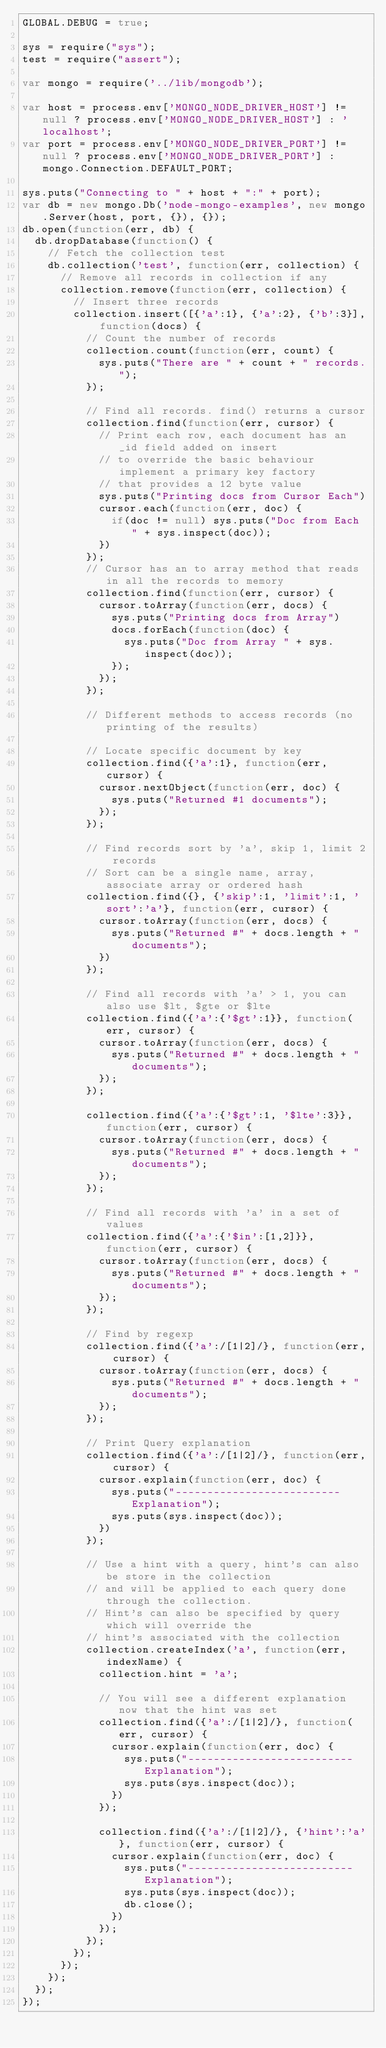<code> <loc_0><loc_0><loc_500><loc_500><_JavaScript_>GLOBAL.DEBUG = true;

sys = require("sys");
test = require("assert");

var mongo = require('../lib/mongodb');

var host = process.env['MONGO_NODE_DRIVER_HOST'] != null ? process.env['MONGO_NODE_DRIVER_HOST'] : 'localhost';
var port = process.env['MONGO_NODE_DRIVER_PORT'] != null ? process.env['MONGO_NODE_DRIVER_PORT'] : mongo.Connection.DEFAULT_PORT;

sys.puts("Connecting to " + host + ":" + port);
var db = new mongo.Db('node-mongo-examples', new mongo.Server(host, port, {}), {});
db.open(function(err, db) {
  db.dropDatabase(function() {
    // Fetch the collection test
    db.collection('test', function(err, collection) {
      // Remove all records in collection if any
      collection.remove(function(err, collection) {
        // Insert three records
        collection.insert([{'a':1}, {'a':2}, {'b':3}], function(docs) {
          // Count the number of records
          collection.count(function(err, count) {
            sys.puts("There are " + count + " records.");
          });
          
          // Find all records. find() returns a cursor
          collection.find(function(err, cursor) {
            // Print each row, each document has an _id field added on insert
            // to override the basic behaviour implement a primary key factory
            // that provides a 12 byte value
            sys.puts("Printing docs from Cursor Each")
            cursor.each(function(err, doc) {
              if(doc != null) sys.puts("Doc from Each " + sys.inspect(doc));
            })                    
          });
          // Cursor has an to array method that reads in all the records to memory
          collection.find(function(err, cursor) {
            cursor.toArray(function(err, docs) {
              sys.puts("Printing docs from Array")
              docs.forEach(function(doc) {
                sys.puts("Doc from Array " + sys.inspect(doc));
              });
            });
          });
          
          // Different methods to access records (no printing of the results)
          
          // Locate specific document by key
          collection.find({'a':1}, function(err, cursor) {
            cursor.nextObject(function(err, doc) {            
              sys.puts("Returned #1 documents");
            });
          });
          
          // Find records sort by 'a', skip 1, limit 2 records
          // Sort can be a single name, array, associate array or ordered hash
          collection.find({}, {'skip':1, 'limit':1, 'sort':'a'}, function(err, cursor) {
            cursor.toArray(function(err, docs) {            
              sys.puts("Returned #" + docs.length + " documents");
            })          
          });
          
          // Find all records with 'a' > 1, you can also use $lt, $gte or $lte
          collection.find({'a':{'$gt':1}}, function(err, cursor) {
            cursor.toArray(function(err, docs) {
              sys.puts("Returned #" + docs.length + " documents");
            });
          });
          
          collection.find({'a':{'$gt':1, '$lte':3}}, function(err, cursor) {
            cursor.toArray(function(err, docs) {
              sys.puts("Returned #" + docs.length + " documents");
            });          
          });
          
          // Find all records with 'a' in a set of values
          collection.find({'a':{'$in':[1,2]}}, function(err, cursor) {
            cursor.toArray(function(err, docs) {
              sys.puts("Returned #" + docs.length + " documents");
            });          
          });
          
          // Find by regexp
          collection.find({'a':/[1|2]/}, function(err, cursor) {
            cursor.toArray(function(err, docs) {
              sys.puts("Returned #" + docs.length + " documents");
            });          
          });

          // Print Query explanation
          collection.find({'a':/[1|2]/}, function(err, cursor) {
            cursor.explain(function(err, doc) {
              sys.puts("-------------------------- Explanation");
              sys.puts(sys.inspect(doc));
            })
          });

          // Use a hint with a query, hint's can also be store in the collection
          // and will be applied to each query done through the collection.
          // Hint's can also be specified by query which will override the 
          // hint's associated with the collection
          collection.createIndex('a', function(err, indexName) {
            collection.hint = 'a';

            // You will see a different explanation now that the hint was set
            collection.find({'a':/[1|2]/}, function(err, cursor) {
              cursor.explain(function(err, doc) {
                sys.puts("-------------------------- Explanation");
                sys.puts(sys.inspect(doc));
              })
            });

            collection.find({'a':/[1|2]/}, {'hint':'a'}, function(err, cursor) {
              cursor.explain(function(err, doc) {
                sys.puts("-------------------------- Explanation");
                sys.puts(sys.inspect(doc));
                db.close();
              })
            });
          });    
        });
      });
    });    
  });
});
</code> 